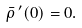<formula> <loc_0><loc_0><loc_500><loc_500>\bar { \rho } \, ^ { \prime } ( 0 ) = 0 .</formula> 